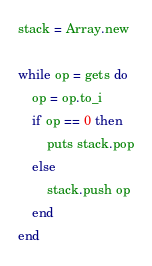Convert code to text. <code><loc_0><loc_0><loc_500><loc_500><_Ruby_>stack = Array.new

while op = gets do
    op = op.to_i
    if op == 0 then
        puts stack.pop
    else
        stack.push op
    end
end</code> 